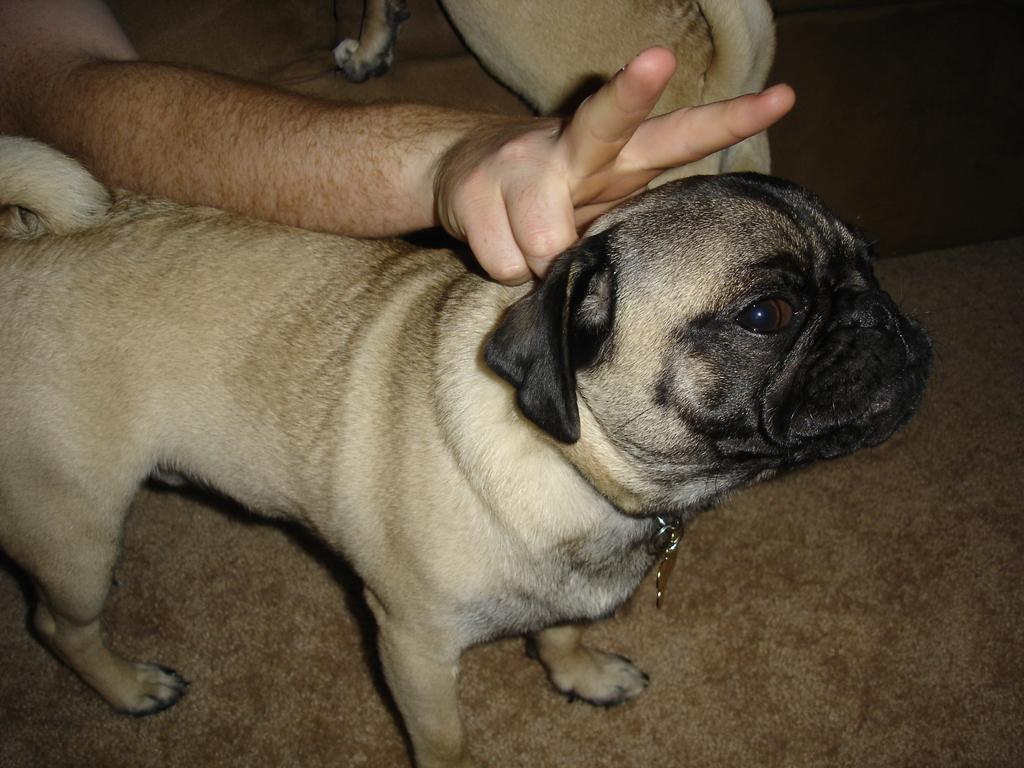In one or two sentences, can you explain what this image depicts? In this image there are dogs and we can see a person's hand. 